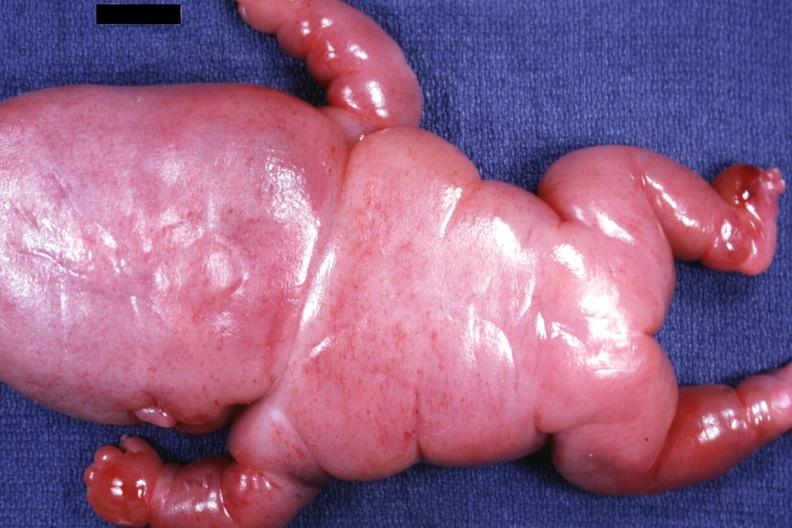s lymphangiomatosis generalized present?
Answer the question using a single word or phrase. Yes 